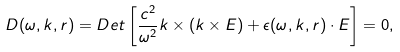Convert formula to latex. <formula><loc_0><loc_0><loc_500><loc_500>D ( \omega , k , r ) = D e t \left [ \frac { c ^ { 2 } } { \omega ^ { 2 } } k \times ( k \times E ) + \epsilon ( \omega , k , r ) \cdot E \right ] = 0 ,</formula> 